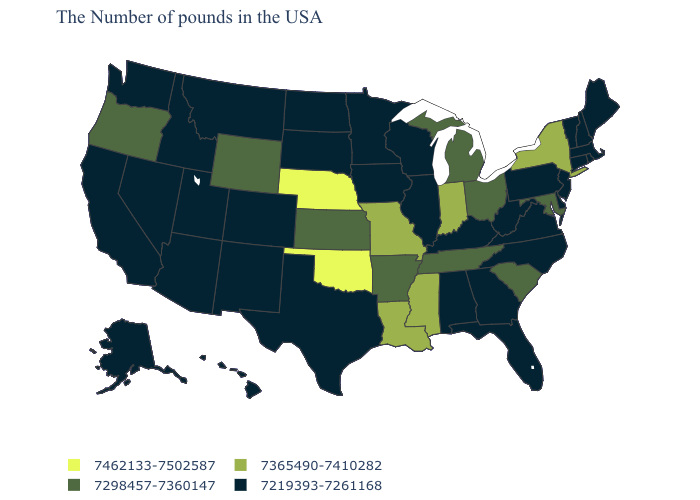What is the highest value in the USA?
Write a very short answer. 7462133-7502587. What is the highest value in the West ?
Write a very short answer. 7298457-7360147. Which states have the highest value in the USA?
Answer briefly. Nebraska, Oklahoma. Name the states that have a value in the range 7365490-7410282?
Answer briefly. New York, Indiana, Mississippi, Louisiana, Missouri. What is the value of Idaho?
Be succinct. 7219393-7261168. Does Oklahoma have the lowest value in the USA?
Quick response, please. No. Does Wyoming have the lowest value in the West?
Answer briefly. No. Does Ohio have the highest value in the MidWest?
Be succinct. No. Name the states that have a value in the range 7365490-7410282?
Write a very short answer. New York, Indiana, Mississippi, Louisiana, Missouri. Which states have the lowest value in the USA?
Be succinct. Maine, Massachusetts, Rhode Island, New Hampshire, Vermont, Connecticut, New Jersey, Delaware, Pennsylvania, Virginia, North Carolina, West Virginia, Florida, Georgia, Kentucky, Alabama, Wisconsin, Illinois, Minnesota, Iowa, Texas, South Dakota, North Dakota, Colorado, New Mexico, Utah, Montana, Arizona, Idaho, Nevada, California, Washington, Alaska, Hawaii. Does the first symbol in the legend represent the smallest category?
Write a very short answer. No. Among the states that border Alabama , which have the lowest value?
Concise answer only. Florida, Georgia. What is the lowest value in the USA?
Short answer required. 7219393-7261168. What is the highest value in the USA?
Concise answer only. 7462133-7502587. 